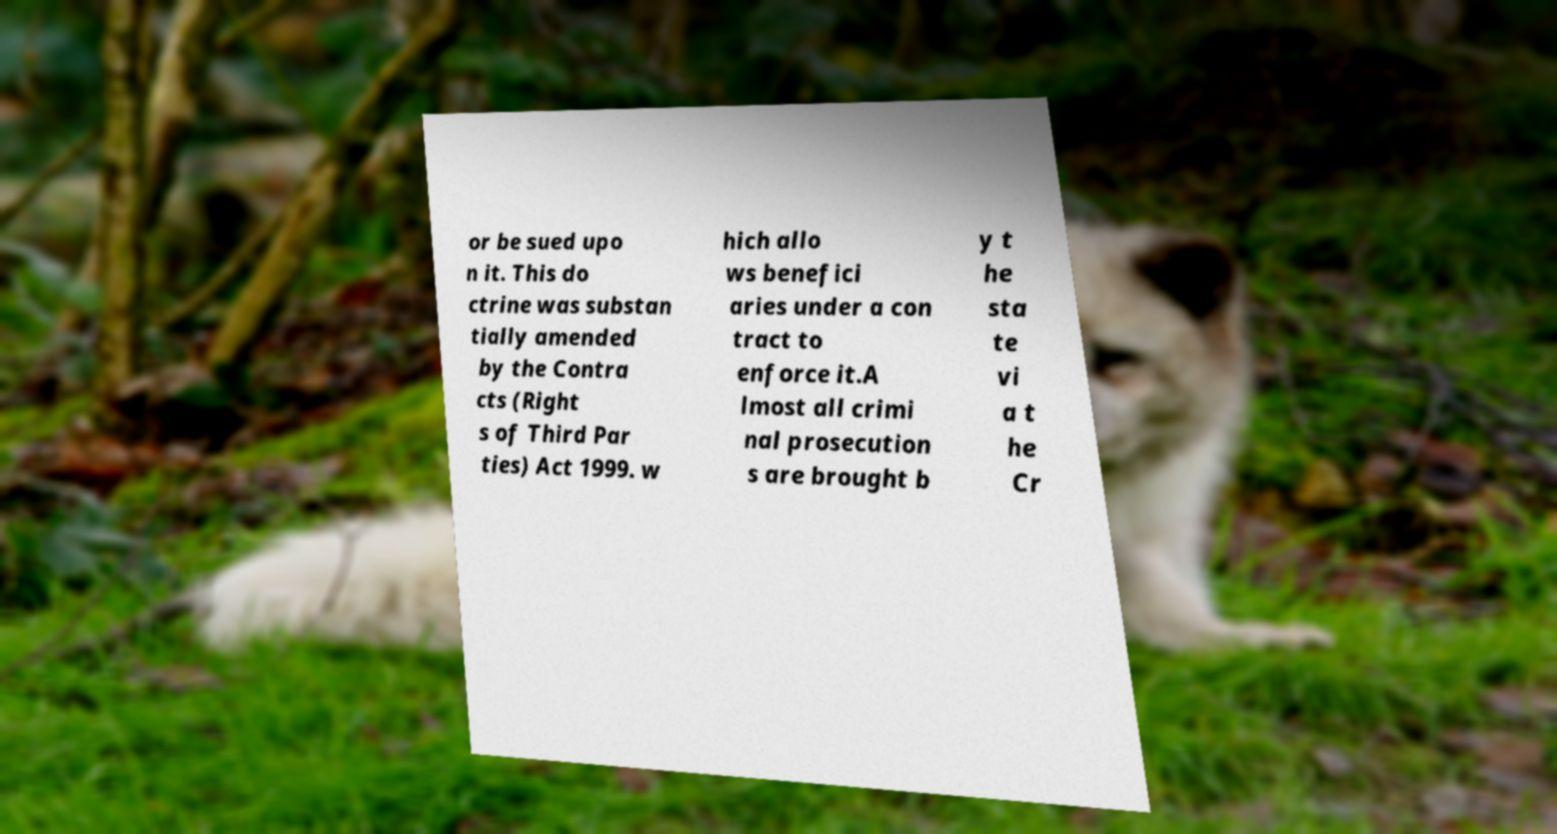What messages or text are displayed in this image? I need them in a readable, typed format. or be sued upo n it. This do ctrine was substan tially amended by the Contra cts (Right s of Third Par ties) Act 1999. w hich allo ws benefici aries under a con tract to enforce it.A lmost all crimi nal prosecution s are brought b y t he sta te vi a t he Cr 